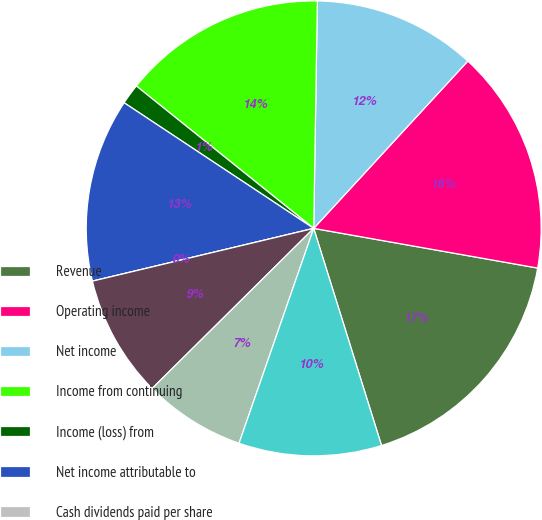<chart> <loc_0><loc_0><loc_500><loc_500><pie_chart><fcel>Revenue<fcel>Operating income<fcel>Net income<fcel>Income from continuing<fcel>Income (loss) from<fcel>Net income attributable to<fcel>Cash dividends paid per share<fcel>High<fcel>Low<fcel>Operating income (loss)<nl><fcel>17.39%<fcel>15.94%<fcel>11.59%<fcel>14.49%<fcel>1.45%<fcel>13.04%<fcel>0.0%<fcel>8.7%<fcel>7.25%<fcel>10.14%<nl></chart> 